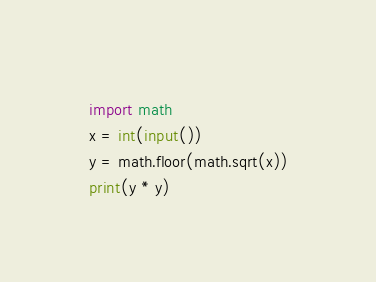<code> <loc_0><loc_0><loc_500><loc_500><_Python_>import math
x = int(input())
y = math.floor(math.sqrt(x))
print(y * y)</code> 